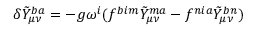Convert formula to latex. <formula><loc_0><loc_0><loc_500><loc_500>\delta \tilde { Y } _ { \mu \nu } ^ { b a } = - g \omega ^ { i } ( f ^ { b i m } \tilde { Y } _ { \mu \nu } ^ { m a } - f ^ { n i a } \tilde { Y } _ { \mu \nu } ^ { b n } )</formula> 